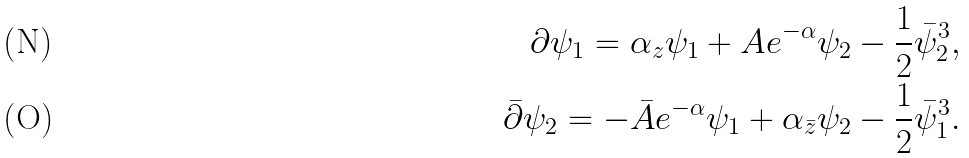<formula> <loc_0><loc_0><loc_500><loc_500>\partial \psi _ { 1 } = \alpha _ { z } \psi _ { 1 } + A e ^ { - \alpha } \psi _ { 2 } - \frac { 1 } { 2 } \bar { \psi } _ { 2 } ^ { 3 } , \\ \bar { \partial } \psi _ { 2 } = - \bar { A } e ^ { - \alpha } \psi _ { 1 } + \alpha _ { \bar { z } } \psi _ { 2 } - \frac { 1 } { 2 } \bar { \psi } _ { 1 } ^ { 3 } .</formula> 